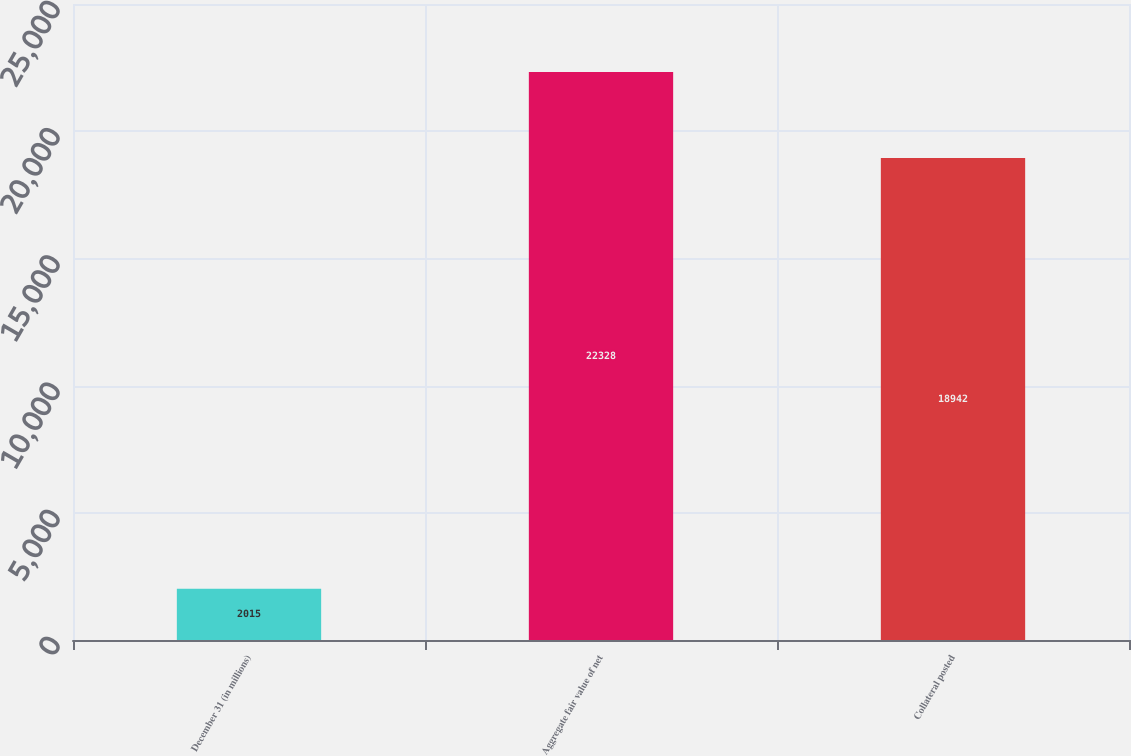Convert chart. <chart><loc_0><loc_0><loc_500><loc_500><bar_chart><fcel>December 31 (in millions)<fcel>Aggregate fair value of net<fcel>Collateral posted<nl><fcel>2015<fcel>22328<fcel>18942<nl></chart> 